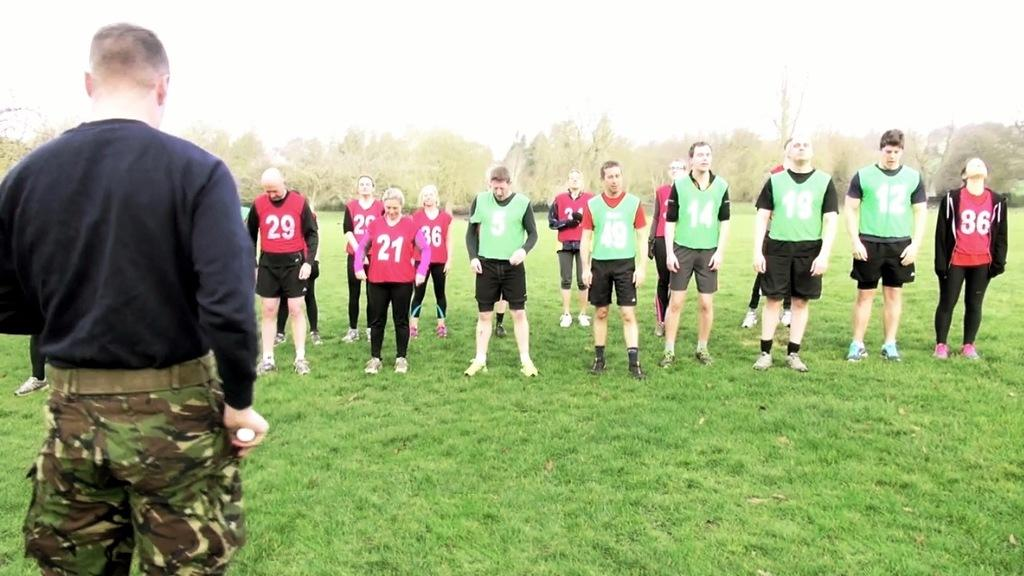What is the primary vegetation covering the land in the image? The land is covered with grass. What are the people in the image doing? There is a group of people standing people standing. What can be seen in the distance in the image? There are trees in the distance. What type of wren can be seen perched on the cork in the image? There is no wren or cork present in the image; the land is covered with grass, and there are trees in the distance. 